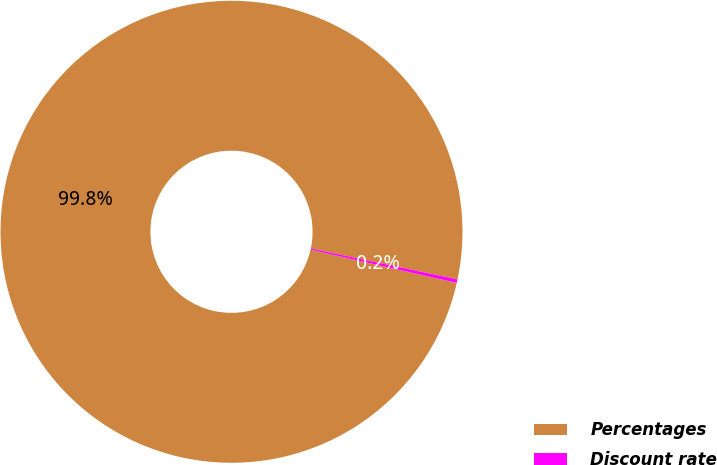Convert chart. <chart><loc_0><loc_0><loc_500><loc_500><pie_chart><fcel>Percentages<fcel>Discount rate<nl><fcel>99.75%<fcel>0.25%<nl></chart> 